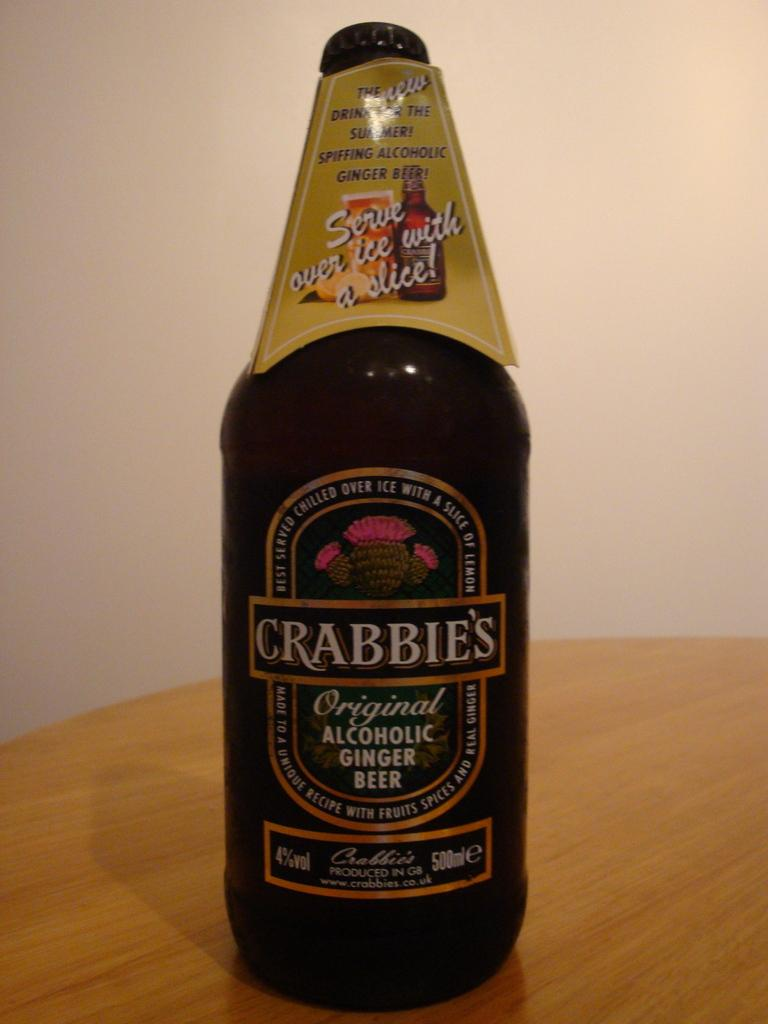<image>
Create a compact narrative representing the image presented. A bottle of Crabbies is an alcoholic ginger ale. 